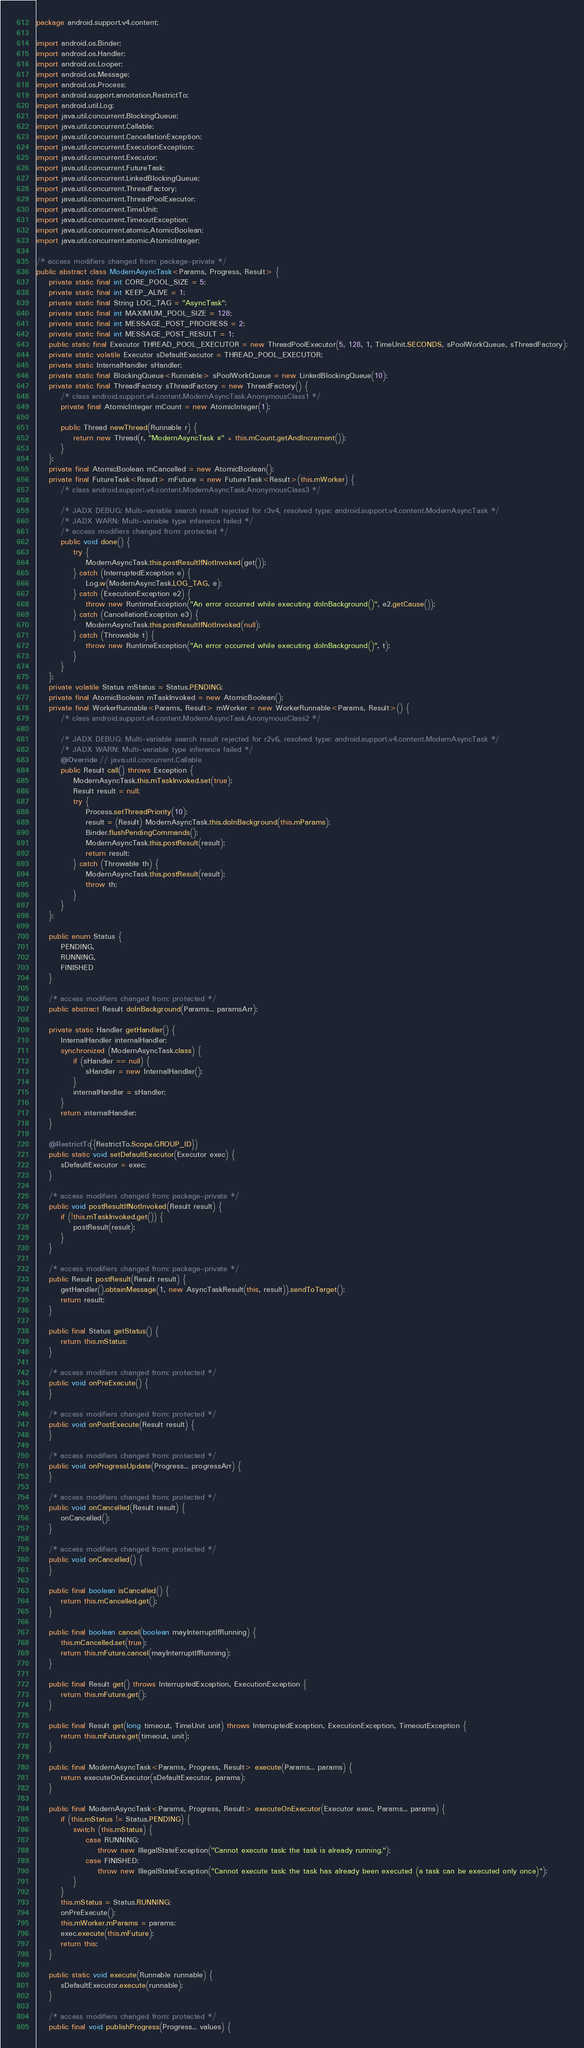Convert code to text. <code><loc_0><loc_0><loc_500><loc_500><_Java_>package android.support.v4.content;

import android.os.Binder;
import android.os.Handler;
import android.os.Looper;
import android.os.Message;
import android.os.Process;
import android.support.annotation.RestrictTo;
import android.util.Log;
import java.util.concurrent.BlockingQueue;
import java.util.concurrent.Callable;
import java.util.concurrent.CancellationException;
import java.util.concurrent.ExecutionException;
import java.util.concurrent.Executor;
import java.util.concurrent.FutureTask;
import java.util.concurrent.LinkedBlockingQueue;
import java.util.concurrent.ThreadFactory;
import java.util.concurrent.ThreadPoolExecutor;
import java.util.concurrent.TimeUnit;
import java.util.concurrent.TimeoutException;
import java.util.concurrent.atomic.AtomicBoolean;
import java.util.concurrent.atomic.AtomicInteger;

/* access modifiers changed from: package-private */
public abstract class ModernAsyncTask<Params, Progress, Result> {
    private static final int CORE_POOL_SIZE = 5;
    private static final int KEEP_ALIVE = 1;
    private static final String LOG_TAG = "AsyncTask";
    private static final int MAXIMUM_POOL_SIZE = 128;
    private static final int MESSAGE_POST_PROGRESS = 2;
    private static final int MESSAGE_POST_RESULT = 1;
    public static final Executor THREAD_POOL_EXECUTOR = new ThreadPoolExecutor(5, 128, 1, TimeUnit.SECONDS, sPoolWorkQueue, sThreadFactory);
    private static volatile Executor sDefaultExecutor = THREAD_POOL_EXECUTOR;
    private static InternalHandler sHandler;
    private static final BlockingQueue<Runnable> sPoolWorkQueue = new LinkedBlockingQueue(10);
    private static final ThreadFactory sThreadFactory = new ThreadFactory() {
        /* class android.support.v4.content.ModernAsyncTask.AnonymousClass1 */
        private final AtomicInteger mCount = new AtomicInteger(1);

        public Thread newThread(Runnable r) {
            return new Thread(r, "ModernAsyncTask #" + this.mCount.getAndIncrement());
        }
    };
    private final AtomicBoolean mCancelled = new AtomicBoolean();
    private final FutureTask<Result> mFuture = new FutureTask<Result>(this.mWorker) {
        /* class android.support.v4.content.ModernAsyncTask.AnonymousClass3 */

        /* JADX DEBUG: Multi-variable search result rejected for r3v4, resolved type: android.support.v4.content.ModernAsyncTask */
        /* JADX WARN: Multi-variable type inference failed */
        /* access modifiers changed from: protected */
        public void done() {
            try {
                ModernAsyncTask.this.postResultIfNotInvoked(get());
            } catch (InterruptedException e) {
                Log.w(ModernAsyncTask.LOG_TAG, e);
            } catch (ExecutionException e2) {
                throw new RuntimeException("An error occurred while executing doInBackground()", e2.getCause());
            } catch (CancellationException e3) {
                ModernAsyncTask.this.postResultIfNotInvoked(null);
            } catch (Throwable t) {
                throw new RuntimeException("An error occurred while executing doInBackground()", t);
            }
        }
    };
    private volatile Status mStatus = Status.PENDING;
    private final AtomicBoolean mTaskInvoked = new AtomicBoolean();
    private final WorkerRunnable<Params, Result> mWorker = new WorkerRunnable<Params, Result>() {
        /* class android.support.v4.content.ModernAsyncTask.AnonymousClass2 */

        /* JADX DEBUG: Multi-variable search result rejected for r2v6, resolved type: android.support.v4.content.ModernAsyncTask */
        /* JADX WARN: Multi-variable type inference failed */
        @Override // java.util.concurrent.Callable
        public Result call() throws Exception {
            ModernAsyncTask.this.mTaskInvoked.set(true);
            Result result = null;
            try {
                Process.setThreadPriority(10);
                result = (Result) ModernAsyncTask.this.doInBackground(this.mParams);
                Binder.flushPendingCommands();
                ModernAsyncTask.this.postResult(result);
                return result;
            } catch (Throwable th) {
                ModernAsyncTask.this.postResult(result);
                throw th;
            }
        }
    };

    public enum Status {
        PENDING,
        RUNNING,
        FINISHED
    }

    /* access modifiers changed from: protected */
    public abstract Result doInBackground(Params... paramsArr);

    private static Handler getHandler() {
        InternalHandler internalHandler;
        synchronized (ModernAsyncTask.class) {
            if (sHandler == null) {
                sHandler = new InternalHandler();
            }
            internalHandler = sHandler;
        }
        return internalHandler;
    }

    @RestrictTo({RestrictTo.Scope.GROUP_ID})
    public static void setDefaultExecutor(Executor exec) {
        sDefaultExecutor = exec;
    }

    /* access modifiers changed from: package-private */
    public void postResultIfNotInvoked(Result result) {
        if (!this.mTaskInvoked.get()) {
            postResult(result);
        }
    }

    /* access modifiers changed from: package-private */
    public Result postResult(Result result) {
        getHandler().obtainMessage(1, new AsyncTaskResult(this, result)).sendToTarget();
        return result;
    }

    public final Status getStatus() {
        return this.mStatus;
    }

    /* access modifiers changed from: protected */
    public void onPreExecute() {
    }

    /* access modifiers changed from: protected */
    public void onPostExecute(Result result) {
    }

    /* access modifiers changed from: protected */
    public void onProgressUpdate(Progress... progressArr) {
    }

    /* access modifiers changed from: protected */
    public void onCancelled(Result result) {
        onCancelled();
    }

    /* access modifiers changed from: protected */
    public void onCancelled() {
    }

    public final boolean isCancelled() {
        return this.mCancelled.get();
    }

    public final boolean cancel(boolean mayInterruptIfRunning) {
        this.mCancelled.set(true);
        return this.mFuture.cancel(mayInterruptIfRunning);
    }

    public final Result get() throws InterruptedException, ExecutionException {
        return this.mFuture.get();
    }

    public final Result get(long timeout, TimeUnit unit) throws InterruptedException, ExecutionException, TimeoutException {
        return this.mFuture.get(timeout, unit);
    }

    public final ModernAsyncTask<Params, Progress, Result> execute(Params... params) {
        return executeOnExecutor(sDefaultExecutor, params);
    }

    public final ModernAsyncTask<Params, Progress, Result> executeOnExecutor(Executor exec, Params... params) {
        if (this.mStatus != Status.PENDING) {
            switch (this.mStatus) {
                case RUNNING:
                    throw new IllegalStateException("Cannot execute task: the task is already running.");
                case FINISHED:
                    throw new IllegalStateException("Cannot execute task: the task has already been executed (a task can be executed only once)");
            }
        }
        this.mStatus = Status.RUNNING;
        onPreExecute();
        this.mWorker.mParams = params;
        exec.execute(this.mFuture);
        return this;
    }

    public static void execute(Runnable runnable) {
        sDefaultExecutor.execute(runnable);
    }

    /* access modifiers changed from: protected */
    public final void publishProgress(Progress... values) {</code> 